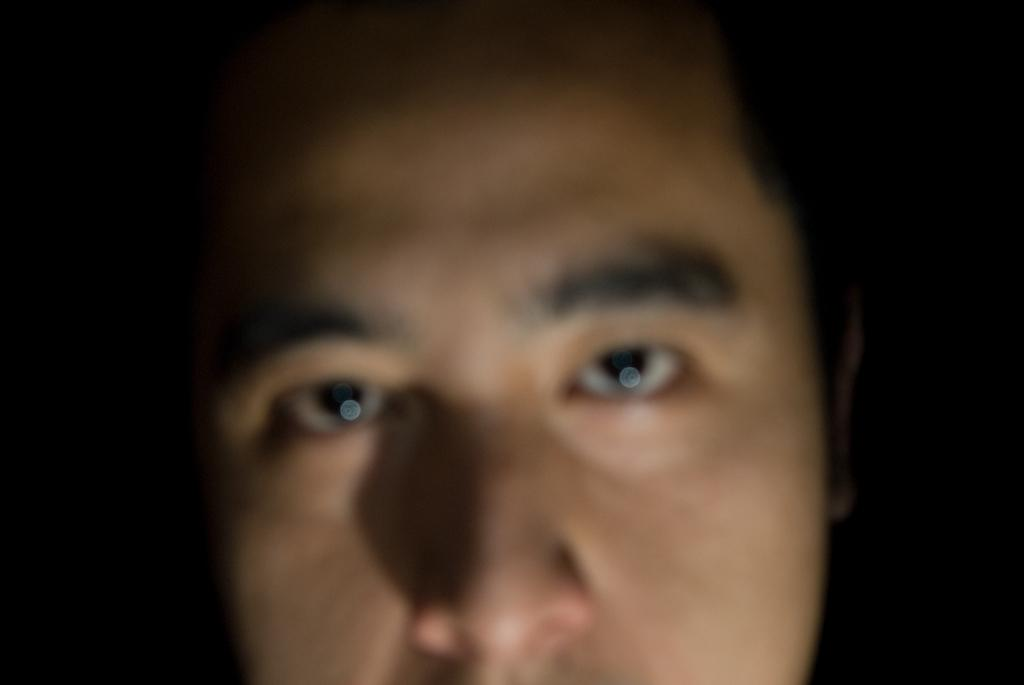What is the main subject of the image? There is a person's face in the image. Can you describe the background of the image? The background of the image is dark. How many pigs are visible in the image? There are no pigs present in the image; it features a person's face. What type of lettuce is being used as a prop in the image? There is no lettuce present in the image. 